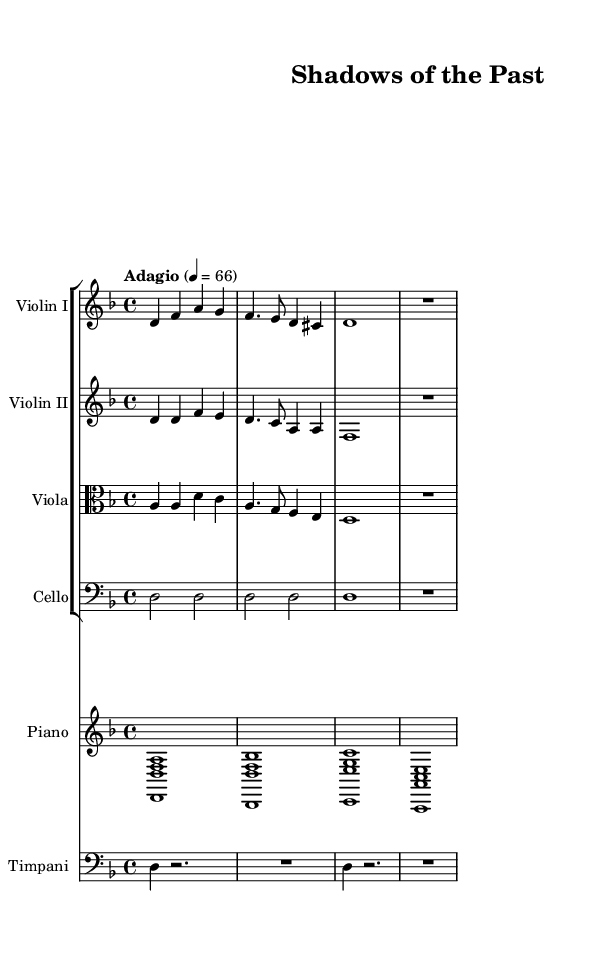What is the key signature of this music? The key signature is D minor, which has one flat (B flat) in the scale. This can be inferred from the initial key signature indication in the score.
Answer: D minor What is the time signature of this music? The time signature is 4/4, which shows that there are four beats in each measure and a quarter note receives one beat. It is clearly notated at the beginning of the score.
Answer: 4/4 What is the tempo marking of this piece? The tempo marking is Adagio, indicated in the score with the term and a metronome marking of 66 beats per minute. This suggests a slow and solemn pace.
Answer: Adagio How many measures does each violin part have before the rest? Each violin part contains four measures before entering the rest, which is indicated by the notation and the pauses following the last notes in their respective sections.
Answer: Four Which instruments are included in the orchestration? The orchestration includes Violin I, Violin II, Viola, Cello, Piano, and Timpani, as indicated by the staff labels in the score. Each instrument is clearly designated in the score layout.
Answer: Violin I, Violin II, Viola, Cello, Piano, Timpani What is the last note played by the Cello? The last note played by the Cello is D, which is indicated at the end of the section and is held for an entire measure, signifying its importance in the composition.
Answer: D What type of ensemble is represented in this piece? The ensemble represented is a string ensemble plus Piano and Timpani, typical of contemporary orchestral soundtracks, allowing for a rich and layered sound throughout the score.
Answer: String ensemble with Piano and Timpani 